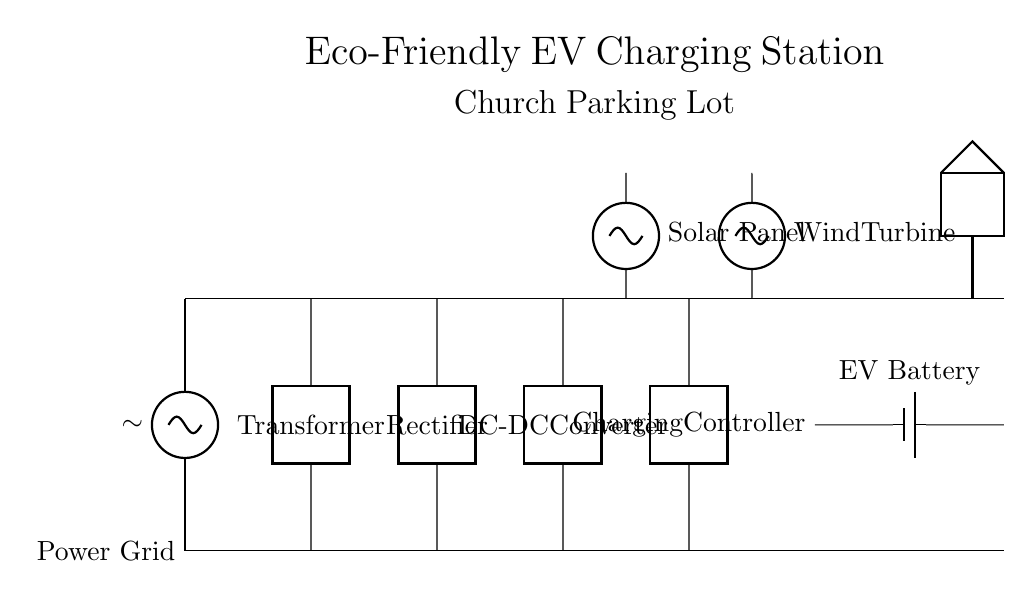What is the power source for the charging station? The circuit shows a connection to a power grid, indicated by the first component labeled as "Power Grid." This is the source supplying power to the entire circuit.
Answer: Power Grid What is the function of the transformer in this circuit? The transformer is marked in the circuit diagram and serves to either step up or step down the voltage according to the needs of the subsequent components. This adjustment helps ensure safe voltage levels for the rectifier that follows it.
Answer: Voltage adjustment How many power sources are depicted in the circuit diagram? The circuit includes two additional renewable power sources: a solar panel and a wind turbine, alongside the power grid. Therefore, there are three total sources depicted.
Answer: Three What type of component is the charging controller? The charging controller is represented as a two-port component in the circuit. Its primary function is to manage power transfer to the electric vehicle battery while ensuring safe charging conditions.
Answer: Two-port component What is the voltage type after the rectifier? Since the rectifier converts AC (alternating current) from the grid and transformer to DC (direct current) for charging, the voltage type after the rectifier will be DC. This is critical for charging electric vehicle batteries that require direct current.
Answer: DC What are the renewable energy sources used in this circuit? The circuit shows a solar panel and a wind turbine contributing to the energy setup, marking the church’s commitment to sustainability and eco-friendliness in powering the charging station.
Answer: Solar panel and wind turbine 